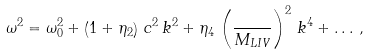Convert formula to latex. <formula><loc_0><loc_0><loc_500><loc_500>\omega ^ { 2 } = \omega _ { 0 } ^ { 2 } + \left ( 1 + \eta _ { 2 } \right ) \, c ^ { 2 } \, k ^ { 2 } + \eta _ { 4 } \, \left ( \frac { } { M _ { L I V } } \right ) ^ { 2 } \, k ^ { 4 } + \dots \, ,</formula> 